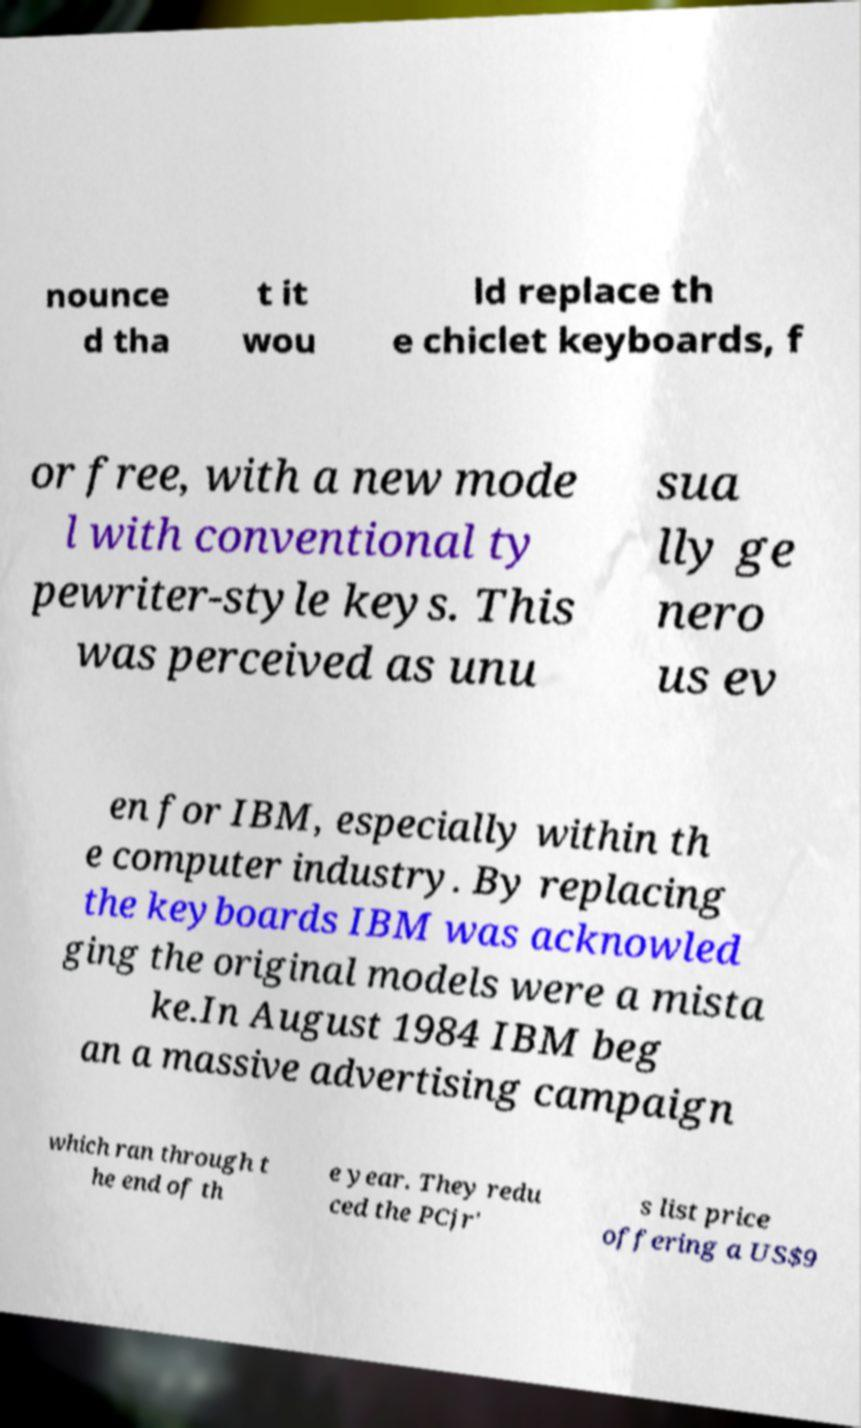There's text embedded in this image that I need extracted. Can you transcribe it verbatim? nounce d tha t it wou ld replace th e chiclet keyboards, f or free, with a new mode l with conventional ty pewriter-style keys. This was perceived as unu sua lly ge nero us ev en for IBM, especially within th e computer industry. By replacing the keyboards IBM was acknowled ging the original models were a mista ke.In August 1984 IBM beg an a massive advertising campaign which ran through t he end of th e year. They redu ced the PCjr' s list price offering a US$9 